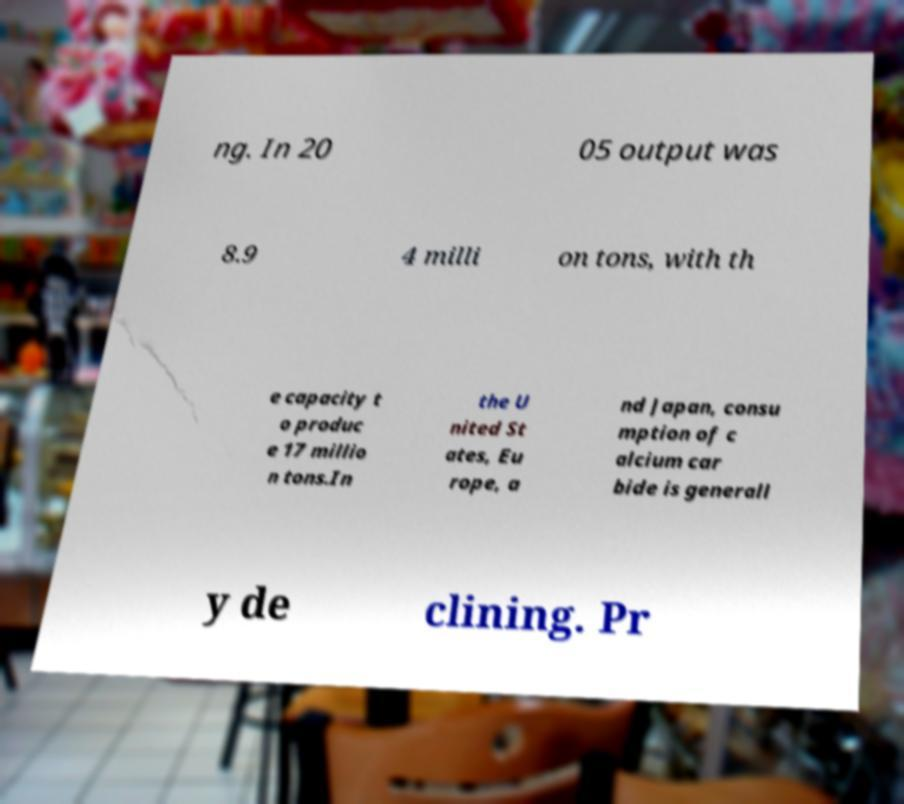Can you read and provide the text displayed in the image?This photo seems to have some interesting text. Can you extract and type it out for me? ng. In 20 05 output was 8.9 4 milli on tons, with th e capacity t o produc e 17 millio n tons.In the U nited St ates, Eu rope, a nd Japan, consu mption of c alcium car bide is generall y de clining. Pr 